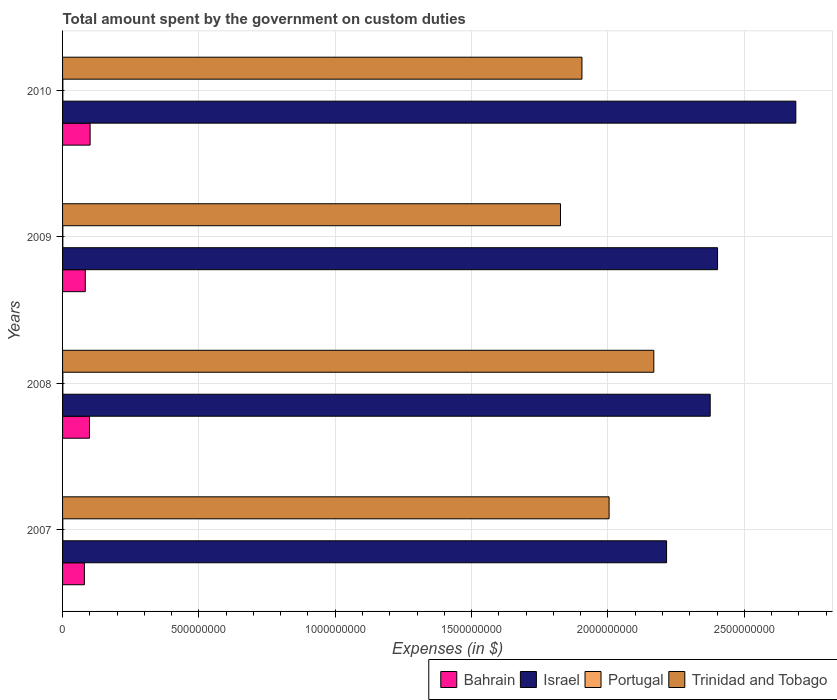How many different coloured bars are there?
Make the answer very short. 4. Are the number of bars per tick equal to the number of legend labels?
Give a very brief answer. Yes. Are the number of bars on each tick of the Y-axis equal?
Offer a terse response. Yes. How many bars are there on the 1st tick from the top?
Provide a short and direct response. 4. How many bars are there on the 4th tick from the bottom?
Offer a terse response. 4. What is the label of the 1st group of bars from the top?
Offer a very short reply. 2010. What is the amount spent on custom duties by the government in Israel in 2007?
Ensure brevity in your answer.  2.22e+09. Across all years, what is the maximum amount spent on custom duties by the government in Israel?
Your answer should be very brief. 2.69e+09. Across all years, what is the minimum amount spent on custom duties by the government in Israel?
Your answer should be very brief. 2.22e+09. In which year was the amount spent on custom duties by the government in Trinidad and Tobago maximum?
Ensure brevity in your answer.  2008. What is the total amount spent on custom duties by the government in Portugal in the graph?
Provide a succinct answer. 4.03e+06. What is the difference between the amount spent on custom duties by the government in Bahrain in 2007 and that in 2008?
Your response must be concise. -1.86e+07. What is the difference between the amount spent on custom duties by the government in Portugal in 2010 and the amount spent on custom duties by the government in Bahrain in 2007?
Keep it short and to the point. -7.90e+07. What is the average amount spent on custom duties by the government in Israel per year?
Your response must be concise. 2.42e+09. In the year 2009, what is the difference between the amount spent on custom duties by the government in Bahrain and amount spent on custom duties by the government in Israel?
Make the answer very short. -2.32e+09. What is the ratio of the amount spent on custom duties by the government in Bahrain in 2008 to that in 2009?
Offer a very short reply. 1.18. Is the difference between the amount spent on custom duties by the government in Bahrain in 2007 and 2009 greater than the difference between the amount spent on custom duties by the government in Israel in 2007 and 2009?
Provide a short and direct response. Yes. What is the difference between the highest and the second highest amount spent on custom duties by the government in Trinidad and Tobago?
Offer a terse response. 1.64e+08. What is the difference between the highest and the lowest amount spent on custom duties by the government in Trinidad and Tobago?
Offer a very short reply. 3.42e+08. Is the sum of the amount spent on custom duties by the government in Trinidad and Tobago in 2008 and 2010 greater than the maximum amount spent on custom duties by the government in Israel across all years?
Keep it short and to the point. Yes. Is it the case that in every year, the sum of the amount spent on custom duties by the government in Portugal and amount spent on custom duties by the government in Bahrain is greater than the sum of amount spent on custom duties by the government in Trinidad and Tobago and amount spent on custom duties by the government in Israel?
Your answer should be very brief. No. What does the 4th bar from the top in 2009 represents?
Provide a succinct answer. Bahrain. What does the 4th bar from the bottom in 2007 represents?
Your answer should be compact. Trinidad and Tobago. Is it the case that in every year, the sum of the amount spent on custom duties by the government in Portugal and amount spent on custom duties by the government in Bahrain is greater than the amount spent on custom duties by the government in Trinidad and Tobago?
Give a very brief answer. No. How many bars are there?
Your response must be concise. 16. What is the difference between two consecutive major ticks on the X-axis?
Offer a very short reply. 5.00e+08. Are the values on the major ticks of X-axis written in scientific E-notation?
Provide a short and direct response. No. Does the graph contain any zero values?
Your response must be concise. No. Where does the legend appear in the graph?
Give a very brief answer. Bottom right. How many legend labels are there?
Your answer should be compact. 4. How are the legend labels stacked?
Make the answer very short. Horizontal. What is the title of the graph?
Your answer should be compact. Total amount spent by the government on custom duties. What is the label or title of the X-axis?
Keep it short and to the point. Expenses (in $). What is the label or title of the Y-axis?
Offer a terse response. Years. What is the Expenses (in $) in Bahrain in 2007?
Provide a short and direct response. 8.01e+07. What is the Expenses (in $) of Israel in 2007?
Provide a succinct answer. 2.22e+09. What is the Expenses (in $) of Portugal in 2007?
Your response must be concise. 8.90e+05. What is the Expenses (in $) in Trinidad and Tobago in 2007?
Make the answer very short. 2.00e+09. What is the Expenses (in $) in Bahrain in 2008?
Give a very brief answer. 9.86e+07. What is the Expenses (in $) of Israel in 2008?
Your answer should be very brief. 2.38e+09. What is the Expenses (in $) in Portugal in 2008?
Your response must be concise. 1.09e+06. What is the Expenses (in $) in Trinidad and Tobago in 2008?
Your answer should be compact. 2.17e+09. What is the Expenses (in $) in Bahrain in 2009?
Offer a very short reply. 8.33e+07. What is the Expenses (in $) in Israel in 2009?
Keep it short and to the point. 2.40e+09. What is the Expenses (in $) in Portugal in 2009?
Give a very brief answer. 9.90e+05. What is the Expenses (in $) of Trinidad and Tobago in 2009?
Your answer should be very brief. 1.83e+09. What is the Expenses (in $) in Bahrain in 2010?
Ensure brevity in your answer.  1.01e+08. What is the Expenses (in $) of Israel in 2010?
Offer a very short reply. 2.69e+09. What is the Expenses (in $) in Portugal in 2010?
Your answer should be compact. 1.06e+06. What is the Expenses (in $) in Trinidad and Tobago in 2010?
Provide a succinct answer. 1.90e+09. Across all years, what is the maximum Expenses (in $) of Bahrain?
Provide a short and direct response. 1.01e+08. Across all years, what is the maximum Expenses (in $) of Israel?
Your response must be concise. 2.69e+09. Across all years, what is the maximum Expenses (in $) of Portugal?
Offer a very short reply. 1.09e+06. Across all years, what is the maximum Expenses (in $) of Trinidad and Tobago?
Your response must be concise. 2.17e+09. Across all years, what is the minimum Expenses (in $) of Bahrain?
Ensure brevity in your answer.  8.01e+07. Across all years, what is the minimum Expenses (in $) in Israel?
Offer a very short reply. 2.22e+09. Across all years, what is the minimum Expenses (in $) in Portugal?
Your answer should be compact. 8.90e+05. Across all years, what is the minimum Expenses (in $) in Trinidad and Tobago?
Make the answer very short. 1.83e+09. What is the total Expenses (in $) of Bahrain in the graph?
Make the answer very short. 3.63e+08. What is the total Expenses (in $) in Israel in the graph?
Your response must be concise. 9.68e+09. What is the total Expenses (in $) in Portugal in the graph?
Ensure brevity in your answer.  4.03e+06. What is the total Expenses (in $) in Trinidad and Tobago in the graph?
Provide a short and direct response. 7.90e+09. What is the difference between the Expenses (in $) in Bahrain in 2007 and that in 2008?
Your answer should be compact. -1.86e+07. What is the difference between the Expenses (in $) in Israel in 2007 and that in 2008?
Your answer should be very brief. -1.60e+08. What is the difference between the Expenses (in $) of Portugal in 2007 and that in 2008?
Provide a succinct answer. -2.00e+05. What is the difference between the Expenses (in $) of Trinidad and Tobago in 2007 and that in 2008?
Ensure brevity in your answer.  -1.64e+08. What is the difference between the Expenses (in $) in Bahrain in 2007 and that in 2009?
Your answer should be compact. -3.25e+06. What is the difference between the Expenses (in $) in Israel in 2007 and that in 2009?
Offer a very short reply. -1.87e+08. What is the difference between the Expenses (in $) in Trinidad and Tobago in 2007 and that in 2009?
Provide a succinct answer. 1.78e+08. What is the difference between the Expenses (in $) in Bahrain in 2007 and that in 2010?
Offer a very short reply. -2.10e+07. What is the difference between the Expenses (in $) of Israel in 2007 and that in 2010?
Provide a succinct answer. -4.74e+08. What is the difference between the Expenses (in $) of Portugal in 2007 and that in 2010?
Provide a short and direct response. -1.70e+05. What is the difference between the Expenses (in $) in Trinidad and Tobago in 2007 and that in 2010?
Keep it short and to the point. 9.95e+07. What is the difference between the Expenses (in $) in Bahrain in 2008 and that in 2009?
Provide a short and direct response. 1.53e+07. What is the difference between the Expenses (in $) of Israel in 2008 and that in 2009?
Make the answer very short. -2.70e+07. What is the difference between the Expenses (in $) of Trinidad and Tobago in 2008 and that in 2009?
Give a very brief answer. 3.42e+08. What is the difference between the Expenses (in $) of Bahrain in 2008 and that in 2010?
Make the answer very short. -2.36e+06. What is the difference between the Expenses (in $) in Israel in 2008 and that in 2010?
Provide a succinct answer. -3.14e+08. What is the difference between the Expenses (in $) of Trinidad and Tobago in 2008 and that in 2010?
Ensure brevity in your answer.  2.64e+08. What is the difference between the Expenses (in $) of Bahrain in 2009 and that in 2010?
Give a very brief answer. -1.77e+07. What is the difference between the Expenses (in $) in Israel in 2009 and that in 2010?
Make the answer very short. -2.87e+08. What is the difference between the Expenses (in $) of Portugal in 2009 and that in 2010?
Your answer should be very brief. -7.00e+04. What is the difference between the Expenses (in $) of Trinidad and Tobago in 2009 and that in 2010?
Your answer should be compact. -7.87e+07. What is the difference between the Expenses (in $) in Bahrain in 2007 and the Expenses (in $) in Israel in 2008?
Your response must be concise. -2.29e+09. What is the difference between the Expenses (in $) of Bahrain in 2007 and the Expenses (in $) of Portugal in 2008?
Your answer should be very brief. 7.90e+07. What is the difference between the Expenses (in $) of Bahrain in 2007 and the Expenses (in $) of Trinidad and Tobago in 2008?
Ensure brevity in your answer.  -2.09e+09. What is the difference between the Expenses (in $) of Israel in 2007 and the Expenses (in $) of Portugal in 2008?
Give a very brief answer. 2.21e+09. What is the difference between the Expenses (in $) of Israel in 2007 and the Expenses (in $) of Trinidad and Tobago in 2008?
Make the answer very short. 4.68e+07. What is the difference between the Expenses (in $) of Portugal in 2007 and the Expenses (in $) of Trinidad and Tobago in 2008?
Keep it short and to the point. -2.17e+09. What is the difference between the Expenses (in $) of Bahrain in 2007 and the Expenses (in $) of Israel in 2009?
Keep it short and to the point. -2.32e+09. What is the difference between the Expenses (in $) in Bahrain in 2007 and the Expenses (in $) in Portugal in 2009?
Make the answer very short. 7.91e+07. What is the difference between the Expenses (in $) of Bahrain in 2007 and the Expenses (in $) of Trinidad and Tobago in 2009?
Ensure brevity in your answer.  -1.75e+09. What is the difference between the Expenses (in $) of Israel in 2007 and the Expenses (in $) of Portugal in 2009?
Make the answer very short. 2.21e+09. What is the difference between the Expenses (in $) of Israel in 2007 and the Expenses (in $) of Trinidad and Tobago in 2009?
Your response must be concise. 3.89e+08. What is the difference between the Expenses (in $) of Portugal in 2007 and the Expenses (in $) of Trinidad and Tobago in 2009?
Provide a short and direct response. -1.83e+09. What is the difference between the Expenses (in $) in Bahrain in 2007 and the Expenses (in $) in Israel in 2010?
Make the answer very short. -2.61e+09. What is the difference between the Expenses (in $) of Bahrain in 2007 and the Expenses (in $) of Portugal in 2010?
Your response must be concise. 7.90e+07. What is the difference between the Expenses (in $) of Bahrain in 2007 and the Expenses (in $) of Trinidad and Tobago in 2010?
Give a very brief answer. -1.82e+09. What is the difference between the Expenses (in $) of Israel in 2007 and the Expenses (in $) of Portugal in 2010?
Your answer should be very brief. 2.21e+09. What is the difference between the Expenses (in $) in Israel in 2007 and the Expenses (in $) in Trinidad and Tobago in 2010?
Ensure brevity in your answer.  3.10e+08. What is the difference between the Expenses (in $) in Portugal in 2007 and the Expenses (in $) in Trinidad and Tobago in 2010?
Offer a very short reply. -1.90e+09. What is the difference between the Expenses (in $) of Bahrain in 2008 and the Expenses (in $) of Israel in 2009?
Offer a terse response. -2.30e+09. What is the difference between the Expenses (in $) in Bahrain in 2008 and the Expenses (in $) in Portugal in 2009?
Give a very brief answer. 9.77e+07. What is the difference between the Expenses (in $) in Bahrain in 2008 and the Expenses (in $) in Trinidad and Tobago in 2009?
Offer a terse response. -1.73e+09. What is the difference between the Expenses (in $) in Israel in 2008 and the Expenses (in $) in Portugal in 2009?
Your answer should be very brief. 2.37e+09. What is the difference between the Expenses (in $) of Israel in 2008 and the Expenses (in $) of Trinidad and Tobago in 2009?
Keep it short and to the point. 5.49e+08. What is the difference between the Expenses (in $) of Portugal in 2008 and the Expenses (in $) of Trinidad and Tobago in 2009?
Your answer should be compact. -1.82e+09. What is the difference between the Expenses (in $) in Bahrain in 2008 and the Expenses (in $) in Israel in 2010?
Keep it short and to the point. -2.59e+09. What is the difference between the Expenses (in $) of Bahrain in 2008 and the Expenses (in $) of Portugal in 2010?
Your response must be concise. 9.76e+07. What is the difference between the Expenses (in $) of Bahrain in 2008 and the Expenses (in $) of Trinidad and Tobago in 2010?
Your response must be concise. -1.81e+09. What is the difference between the Expenses (in $) of Israel in 2008 and the Expenses (in $) of Portugal in 2010?
Your answer should be compact. 2.37e+09. What is the difference between the Expenses (in $) of Israel in 2008 and the Expenses (in $) of Trinidad and Tobago in 2010?
Offer a terse response. 4.70e+08. What is the difference between the Expenses (in $) of Portugal in 2008 and the Expenses (in $) of Trinidad and Tobago in 2010?
Your response must be concise. -1.90e+09. What is the difference between the Expenses (in $) in Bahrain in 2009 and the Expenses (in $) in Israel in 2010?
Your answer should be compact. -2.61e+09. What is the difference between the Expenses (in $) in Bahrain in 2009 and the Expenses (in $) in Portugal in 2010?
Give a very brief answer. 8.22e+07. What is the difference between the Expenses (in $) in Bahrain in 2009 and the Expenses (in $) in Trinidad and Tobago in 2010?
Provide a succinct answer. -1.82e+09. What is the difference between the Expenses (in $) in Israel in 2009 and the Expenses (in $) in Portugal in 2010?
Ensure brevity in your answer.  2.40e+09. What is the difference between the Expenses (in $) of Israel in 2009 and the Expenses (in $) of Trinidad and Tobago in 2010?
Your answer should be very brief. 4.97e+08. What is the difference between the Expenses (in $) in Portugal in 2009 and the Expenses (in $) in Trinidad and Tobago in 2010?
Keep it short and to the point. -1.90e+09. What is the average Expenses (in $) of Bahrain per year?
Ensure brevity in your answer.  9.08e+07. What is the average Expenses (in $) in Israel per year?
Offer a very short reply. 2.42e+09. What is the average Expenses (in $) in Portugal per year?
Give a very brief answer. 1.01e+06. What is the average Expenses (in $) of Trinidad and Tobago per year?
Provide a short and direct response. 1.98e+09. In the year 2007, what is the difference between the Expenses (in $) of Bahrain and Expenses (in $) of Israel?
Your answer should be very brief. -2.13e+09. In the year 2007, what is the difference between the Expenses (in $) in Bahrain and Expenses (in $) in Portugal?
Make the answer very short. 7.92e+07. In the year 2007, what is the difference between the Expenses (in $) in Bahrain and Expenses (in $) in Trinidad and Tobago?
Make the answer very short. -1.92e+09. In the year 2007, what is the difference between the Expenses (in $) in Israel and Expenses (in $) in Portugal?
Give a very brief answer. 2.21e+09. In the year 2007, what is the difference between the Expenses (in $) in Israel and Expenses (in $) in Trinidad and Tobago?
Ensure brevity in your answer.  2.11e+08. In the year 2007, what is the difference between the Expenses (in $) of Portugal and Expenses (in $) of Trinidad and Tobago?
Provide a short and direct response. -2.00e+09. In the year 2008, what is the difference between the Expenses (in $) in Bahrain and Expenses (in $) in Israel?
Provide a succinct answer. -2.28e+09. In the year 2008, what is the difference between the Expenses (in $) in Bahrain and Expenses (in $) in Portugal?
Your response must be concise. 9.76e+07. In the year 2008, what is the difference between the Expenses (in $) in Bahrain and Expenses (in $) in Trinidad and Tobago?
Ensure brevity in your answer.  -2.07e+09. In the year 2008, what is the difference between the Expenses (in $) in Israel and Expenses (in $) in Portugal?
Offer a terse response. 2.37e+09. In the year 2008, what is the difference between the Expenses (in $) in Israel and Expenses (in $) in Trinidad and Tobago?
Provide a succinct answer. 2.07e+08. In the year 2008, what is the difference between the Expenses (in $) in Portugal and Expenses (in $) in Trinidad and Tobago?
Your response must be concise. -2.17e+09. In the year 2009, what is the difference between the Expenses (in $) in Bahrain and Expenses (in $) in Israel?
Keep it short and to the point. -2.32e+09. In the year 2009, what is the difference between the Expenses (in $) of Bahrain and Expenses (in $) of Portugal?
Provide a succinct answer. 8.23e+07. In the year 2009, what is the difference between the Expenses (in $) in Bahrain and Expenses (in $) in Trinidad and Tobago?
Offer a terse response. -1.74e+09. In the year 2009, what is the difference between the Expenses (in $) of Israel and Expenses (in $) of Portugal?
Provide a short and direct response. 2.40e+09. In the year 2009, what is the difference between the Expenses (in $) in Israel and Expenses (in $) in Trinidad and Tobago?
Your answer should be compact. 5.76e+08. In the year 2009, what is the difference between the Expenses (in $) in Portugal and Expenses (in $) in Trinidad and Tobago?
Give a very brief answer. -1.83e+09. In the year 2010, what is the difference between the Expenses (in $) of Bahrain and Expenses (in $) of Israel?
Ensure brevity in your answer.  -2.59e+09. In the year 2010, what is the difference between the Expenses (in $) of Bahrain and Expenses (in $) of Portugal?
Offer a very short reply. 1.00e+08. In the year 2010, what is the difference between the Expenses (in $) in Bahrain and Expenses (in $) in Trinidad and Tobago?
Offer a terse response. -1.80e+09. In the year 2010, what is the difference between the Expenses (in $) of Israel and Expenses (in $) of Portugal?
Make the answer very short. 2.69e+09. In the year 2010, what is the difference between the Expenses (in $) of Israel and Expenses (in $) of Trinidad and Tobago?
Offer a terse response. 7.84e+08. In the year 2010, what is the difference between the Expenses (in $) in Portugal and Expenses (in $) in Trinidad and Tobago?
Provide a short and direct response. -1.90e+09. What is the ratio of the Expenses (in $) in Bahrain in 2007 to that in 2008?
Keep it short and to the point. 0.81. What is the ratio of the Expenses (in $) in Israel in 2007 to that in 2008?
Provide a short and direct response. 0.93. What is the ratio of the Expenses (in $) in Portugal in 2007 to that in 2008?
Give a very brief answer. 0.82. What is the ratio of the Expenses (in $) of Trinidad and Tobago in 2007 to that in 2008?
Offer a very short reply. 0.92. What is the ratio of the Expenses (in $) of Bahrain in 2007 to that in 2009?
Give a very brief answer. 0.96. What is the ratio of the Expenses (in $) of Israel in 2007 to that in 2009?
Keep it short and to the point. 0.92. What is the ratio of the Expenses (in $) of Portugal in 2007 to that in 2009?
Your answer should be compact. 0.9. What is the ratio of the Expenses (in $) in Trinidad and Tobago in 2007 to that in 2009?
Make the answer very short. 1.1. What is the ratio of the Expenses (in $) of Bahrain in 2007 to that in 2010?
Provide a succinct answer. 0.79. What is the ratio of the Expenses (in $) in Israel in 2007 to that in 2010?
Give a very brief answer. 0.82. What is the ratio of the Expenses (in $) of Portugal in 2007 to that in 2010?
Offer a very short reply. 0.84. What is the ratio of the Expenses (in $) of Trinidad and Tobago in 2007 to that in 2010?
Your answer should be very brief. 1.05. What is the ratio of the Expenses (in $) in Bahrain in 2008 to that in 2009?
Make the answer very short. 1.18. What is the ratio of the Expenses (in $) of Portugal in 2008 to that in 2009?
Keep it short and to the point. 1.1. What is the ratio of the Expenses (in $) in Trinidad and Tobago in 2008 to that in 2009?
Provide a short and direct response. 1.19. What is the ratio of the Expenses (in $) of Bahrain in 2008 to that in 2010?
Keep it short and to the point. 0.98. What is the ratio of the Expenses (in $) in Israel in 2008 to that in 2010?
Your answer should be compact. 0.88. What is the ratio of the Expenses (in $) in Portugal in 2008 to that in 2010?
Make the answer very short. 1.03. What is the ratio of the Expenses (in $) in Trinidad and Tobago in 2008 to that in 2010?
Your answer should be very brief. 1.14. What is the ratio of the Expenses (in $) in Bahrain in 2009 to that in 2010?
Ensure brevity in your answer.  0.82. What is the ratio of the Expenses (in $) in Israel in 2009 to that in 2010?
Give a very brief answer. 0.89. What is the ratio of the Expenses (in $) of Portugal in 2009 to that in 2010?
Provide a short and direct response. 0.93. What is the ratio of the Expenses (in $) in Trinidad and Tobago in 2009 to that in 2010?
Provide a succinct answer. 0.96. What is the difference between the highest and the second highest Expenses (in $) of Bahrain?
Offer a very short reply. 2.36e+06. What is the difference between the highest and the second highest Expenses (in $) in Israel?
Offer a very short reply. 2.87e+08. What is the difference between the highest and the second highest Expenses (in $) in Portugal?
Make the answer very short. 3.00e+04. What is the difference between the highest and the second highest Expenses (in $) in Trinidad and Tobago?
Offer a very short reply. 1.64e+08. What is the difference between the highest and the lowest Expenses (in $) of Bahrain?
Give a very brief answer. 2.10e+07. What is the difference between the highest and the lowest Expenses (in $) of Israel?
Make the answer very short. 4.74e+08. What is the difference between the highest and the lowest Expenses (in $) in Portugal?
Your answer should be very brief. 2.00e+05. What is the difference between the highest and the lowest Expenses (in $) of Trinidad and Tobago?
Make the answer very short. 3.42e+08. 